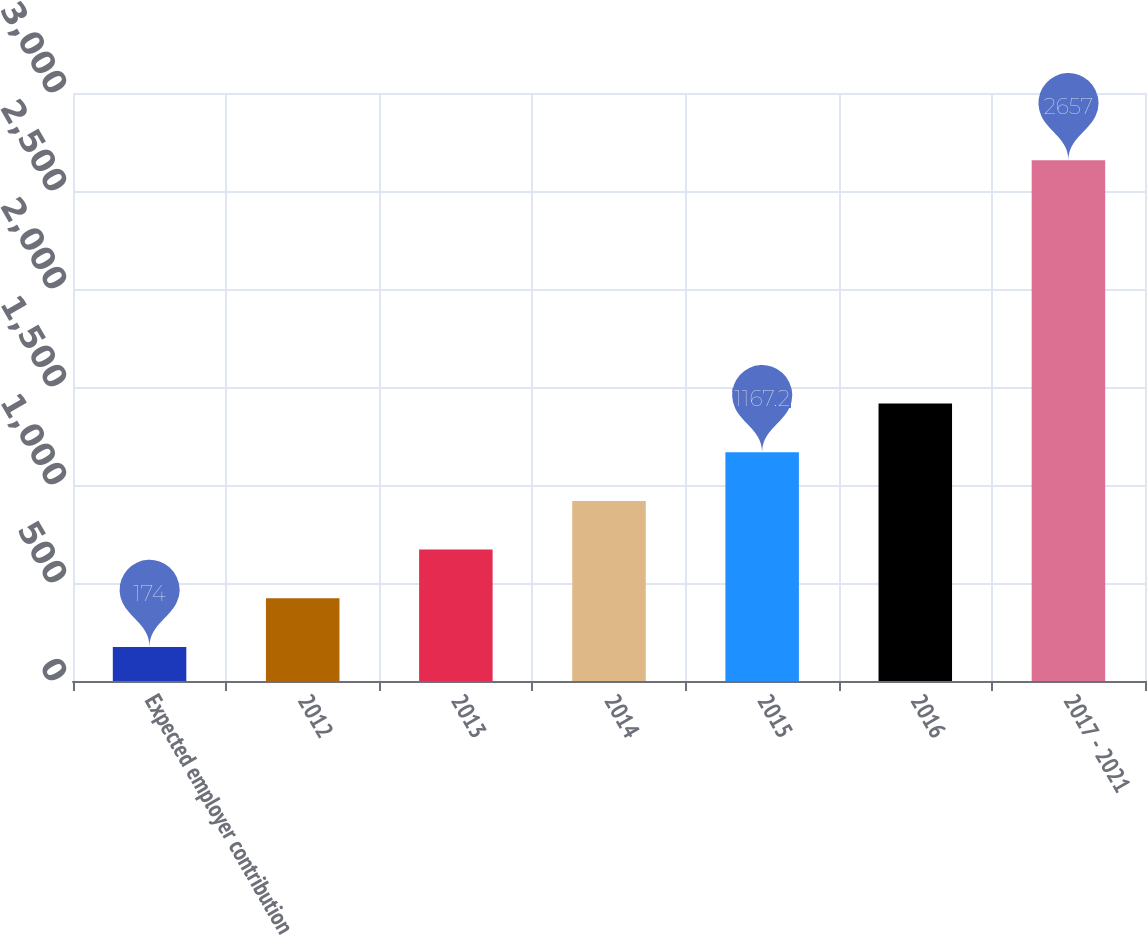Convert chart to OTSL. <chart><loc_0><loc_0><loc_500><loc_500><bar_chart><fcel>Expected employer contribution<fcel>2012<fcel>2013<fcel>2014<fcel>2015<fcel>2016<fcel>2017 - 2021<nl><fcel>174<fcel>422.3<fcel>670.6<fcel>918.9<fcel>1167.2<fcel>1415.5<fcel>2657<nl></chart> 